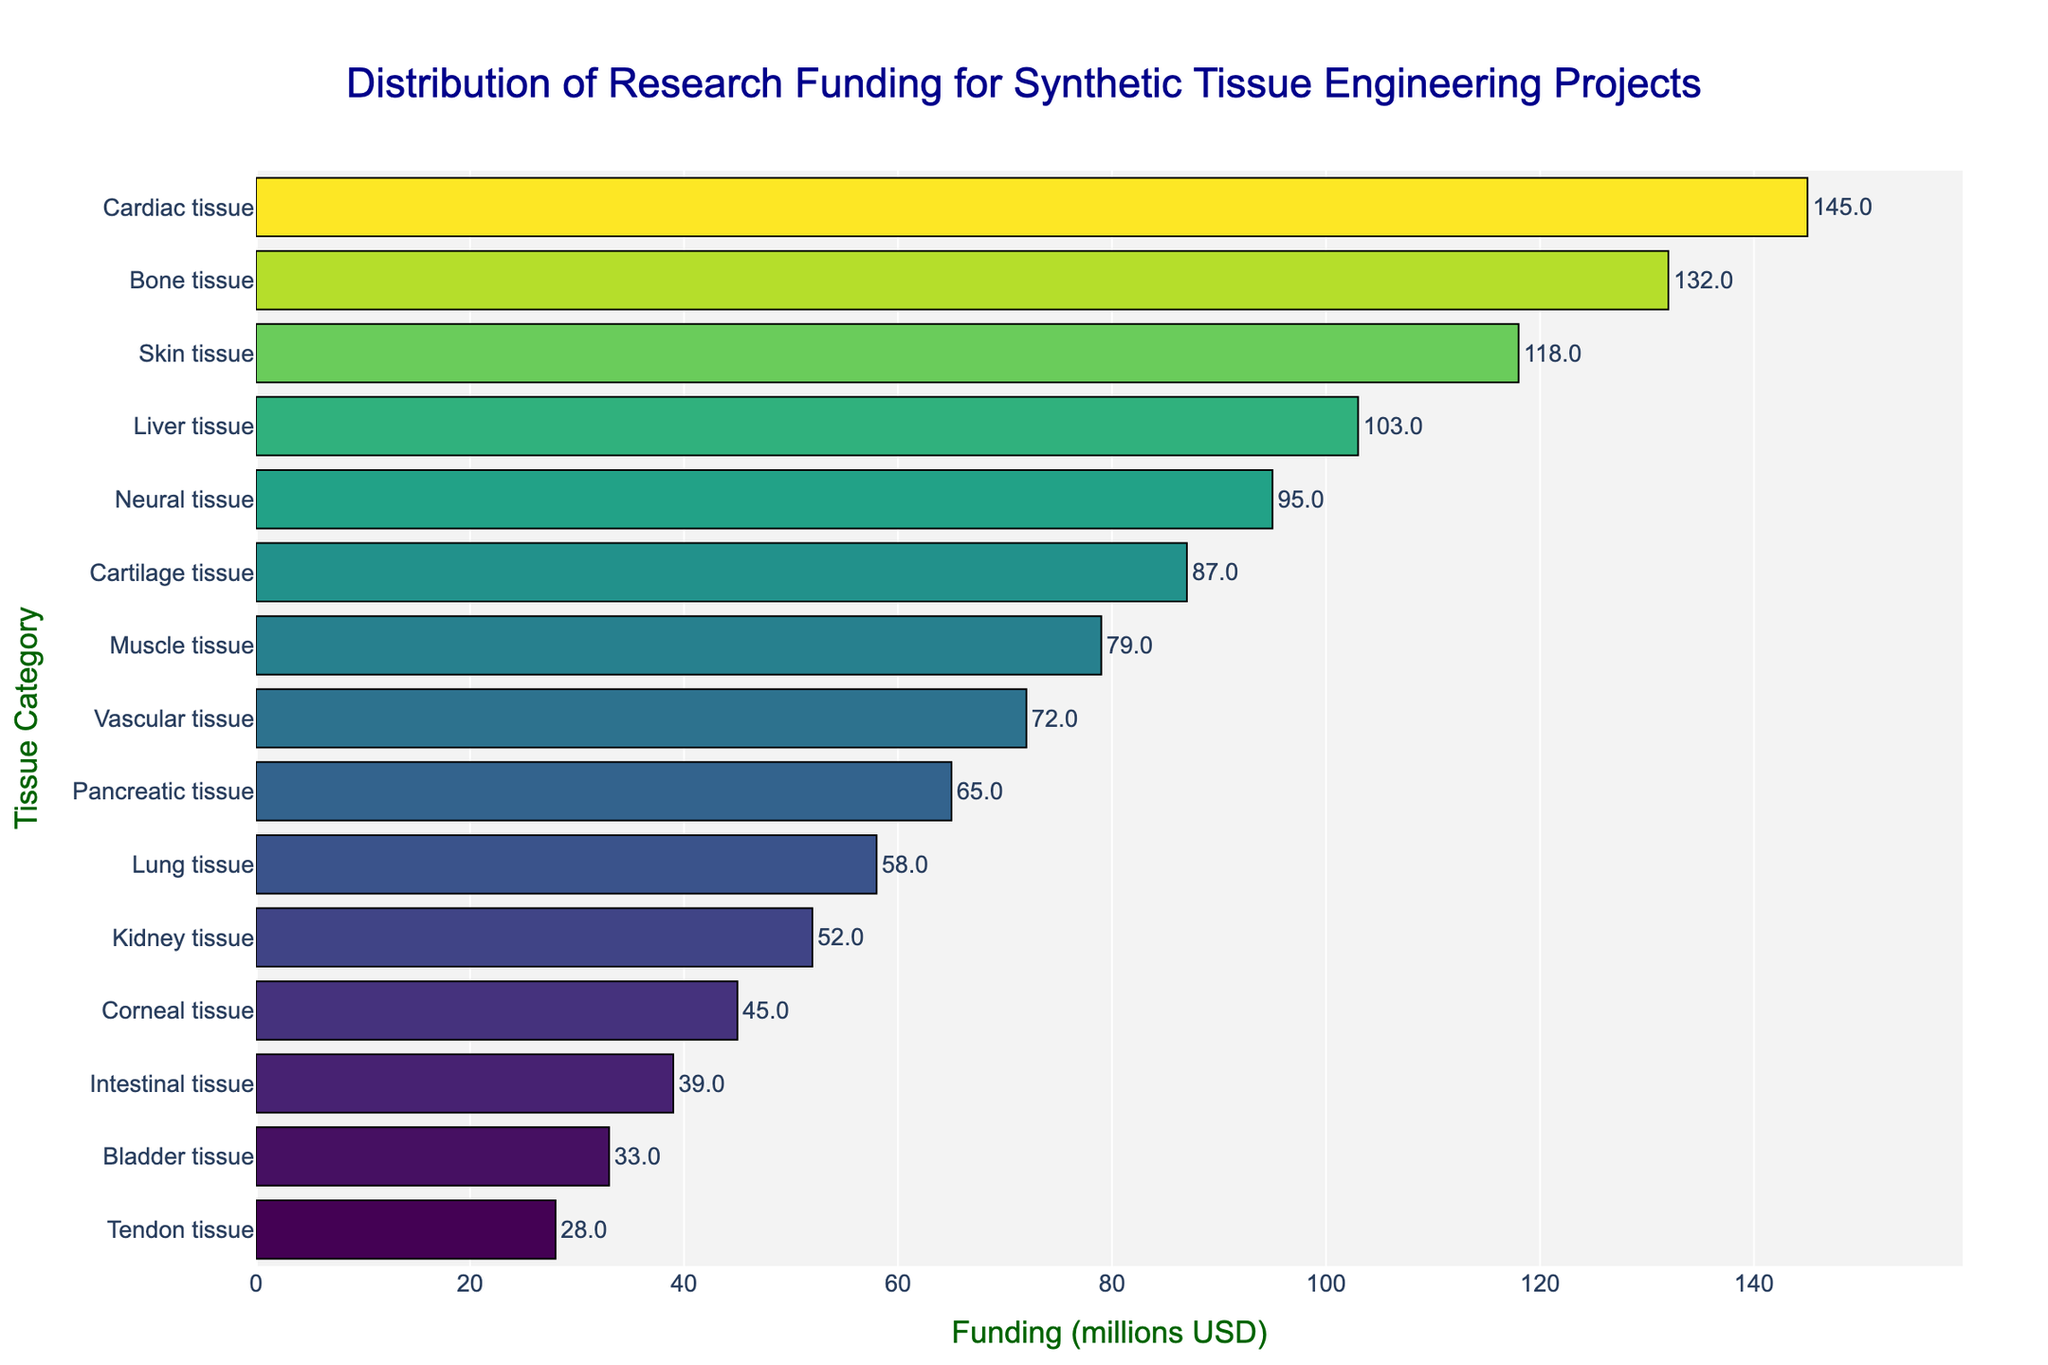Question: Which tissue category has the highest research funding? Explanation: By examining the bar chart, we can observe the length of each bar. The bar representing "Cardiac tissue" is the longest, indicating it has the highest funding.
Answer: Cardiac tissue Question: What is the total funding allocated to Cardiac and Bone tissue projects? Explanation: The funding for Cardiac tissue is 145 million USD, and for Bone tissue, it is 132 million USD. Summing these values gives 145 + 132 = 277 million USD.
Answer: 277 million USD Question: Which tissue category has a funding amount closest to 100 million USD? Explanation: By observing the chart, the tissue categories near 100 million USD are Skin and Liver tissue. Liver tissue has funding of 103 million USD, which is closest to 100 million USD.
Answer: Liver tissue Question: How much more funding does Cardiac tissue receive compared to Neural tissue? Explanation: Cardiac tissue receives 145 million USD, and Neural tissue receives 95 million USD. Subtracting these values gives 145 - 95 = 50 million USD.
Answer: 50 million USD Question: Which two tissue categories have the lowest research funding? Explanation: By observing the very bottom of the chart, the bars for Tendon tissue and Bladder tissue are the shortest, indicating the lowest funding of 28 million USD and 33 million USD respectively.
Answer: Tendon tissue and Bladder tissue Question: What is the total research funding for the three tissue categories with the highest funding? Explanation: The three tissue categories with the highest funding are Cardiac tissue (145 million USD), Bone tissue (132 million USD), and Skin tissue (118 million USD). Summing these values gives 145 + 132 + 118 = 395 million USD.
Answer: 395 million USD Question: How does the funding for Vascular tissue compare to that of Lung tissue? Explanation: Vascular tissue has a funding of 72 million USD, while Lung tissue has 58 million USD. 72 million USD is greater than 58 million USD.
Answer: Vascular tissue has more funding Question: What is the average funding for Neural, Cartilage, and Muscle tissue projects? Explanation: Funding for Neural tissue is 95 million USD, Cartilage tissue is 87 million USD, and Muscle tissue is 79 million USD. Summing these values gives 95 + 87 + 79 = 261 million USD. Dividing by 3 for the average, 261 / 3 = 87 million USD.
Answer: 87 million USD Question: What is the funding range between the highest and lowest funded tissue categories? Explanation: The highest funded category is Cardiac tissue at 145 million USD, and the lowest funded category is Tendon tissue at 28 million USD. Subtracting these values gives 145 - 28 = 117 million USD.
Answer: 117 million USD Question: How many tissue categories have funding above 100 million USD? Explanation: Observing the chart, the tissue categories with funding above 100 million USD are Cardiac, Bone, and Skin tissue, meaning there are 3 categories.
Answer: 3 categories 